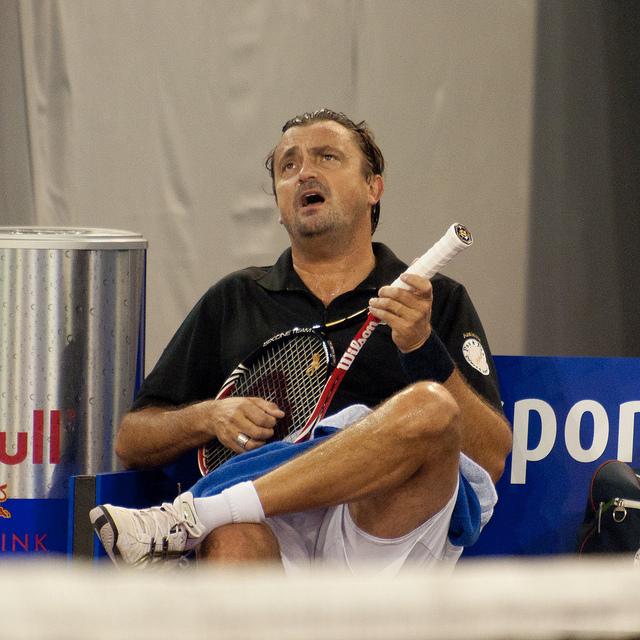What is this man holding like a guitar?
Give a very brief answer. Tennis racket. What is the man singing?
Concise answer only. Song. What color are the man's socks?
Give a very brief answer. White. 